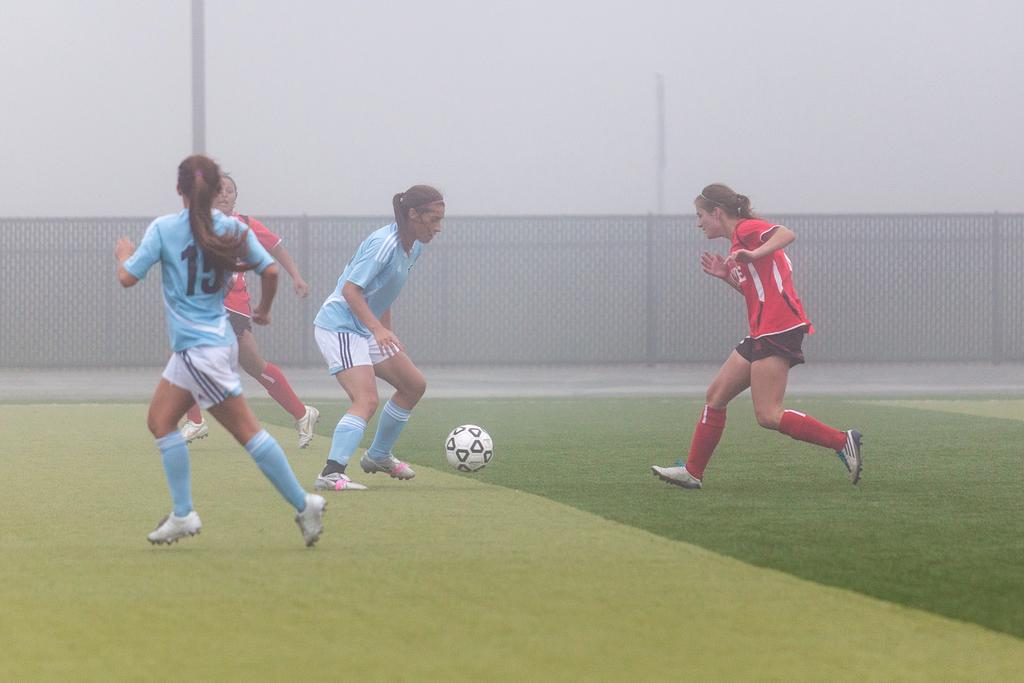How many people are in the image? There are four persons in the image. What are the persons wearing? The persons are wearing clothes. What activity are the persons engaged in? The persons are playing football. What is in the middle of the image? There is a fencing in the middle of the image. What can be seen in the top left of the image? There is a pole in the top left of the image. What type of roll can be seen in the image? There is no roll present in the image. What pen is being used by the persons to write in the image? There is no pen or writing activity depicted in the image. 